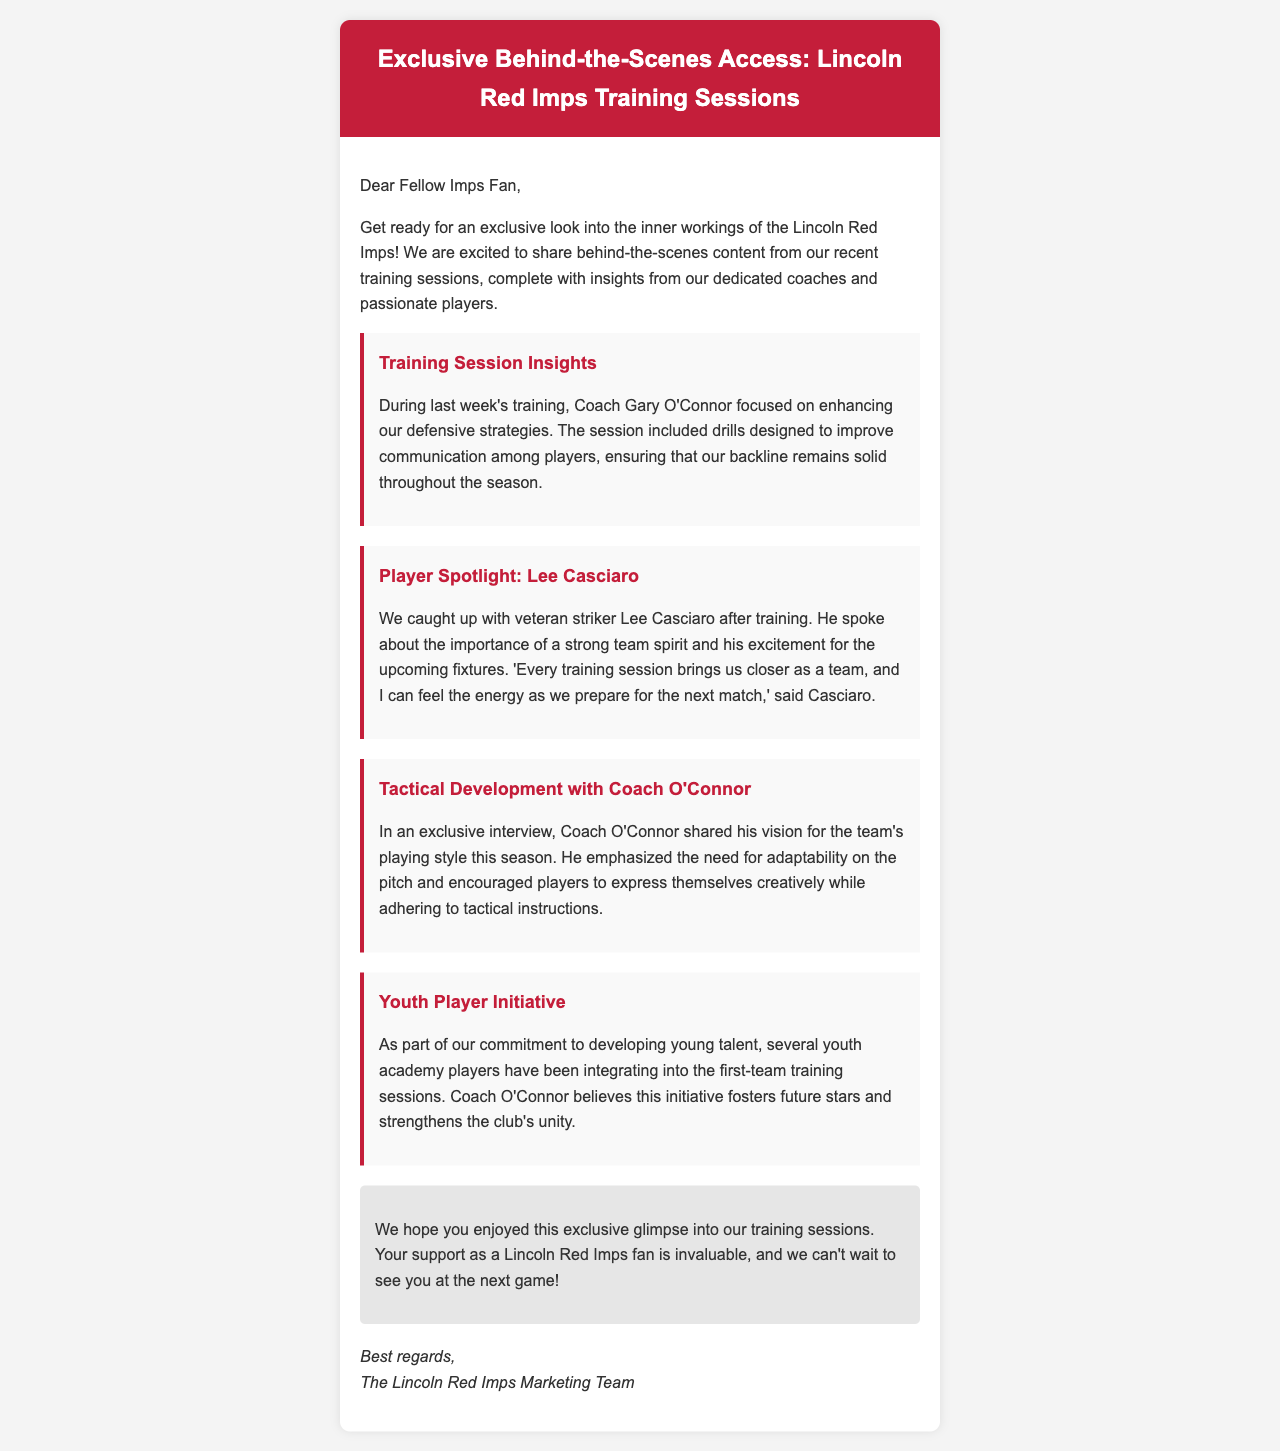what is the title of the email? The title of the email is prominently displayed in the header section, introducing the content.
Answer: Exclusive Behind-the-Scenes Access: Lincoln Red Imps Training Sessions who is the coach mentioned in the document? The document refers to the coach who led the training session and shared insights about the team's strategies.
Answer: Coach Gary O'Connor what is the focus of last week's training session? The document specifically details the primary focus of the training session led by the coach, highlighting its objective.
Answer: Defensive strategies who is the player spotlighted in the email? The email features a specific player in the spotlight section along with his contributions to the team.
Answer: Lee Casciaro what initiative is mentioned regarding youth players? The document discusses a specific program related to the integration of youth players into the first team.
Answer: Youth Player Initiative what is emphasized by Coach O'Connor regarding player performance? The document includes insights from Coach O'Connor that address the expectations from players on the pitch.
Answer: Adaptability how does Lee Casciaro describe the team spirit? The email quotes Lee Casciaro discussing the atmosphere within the team during training sessions.
Answer: Strong team spirit what type of content is being shared with fans? The document addresses the nature of the content that is being provided to the fans.
Answer: Behind-the-scenes content who wrote the email? The signature at the end of the document indicates who is responsible for writing the email to fans.
Answer: The Lincoln Red Imps Marketing Team 